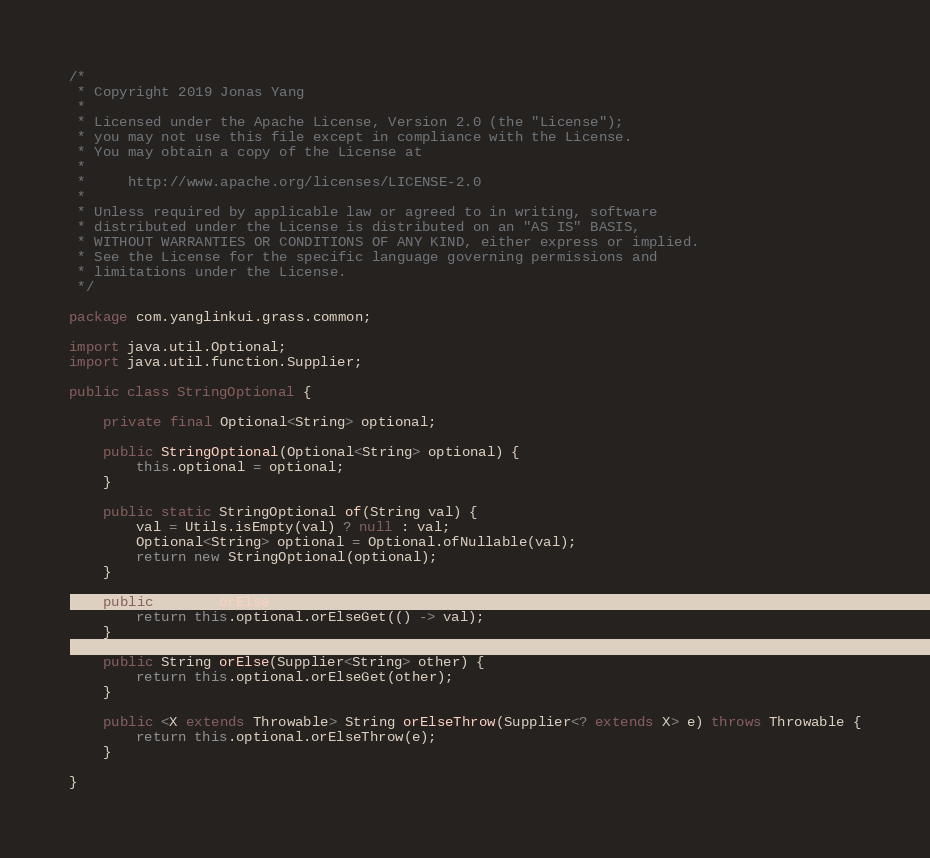Convert code to text. <code><loc_0><loc_0><loc_500><loc_500><_Java_>/*
 * Copyright 2019 Jonas Yang
 *
 * Licensed under the Apache License, Version 2.0 (the "License");
 * you may not use this file except in compliance with the License.
 * You may obtain a copy of the License at
 *
 *     http://www.apache.org/licenses/LICENSE-2.0
 *
 * Unless required by applicable law or agreed to in writing, software
 * distributed under the License is distributed on an "AS IS" BASIS,
 * WITHOUT WARRANTIES OR CONDITIONS OF ANY KIND, either express or implied.
 * See the License for the specific language governing permissions and
 * limitations under the License.
 */

package com.yanglinkui.grass.common;

import java.util.Optional;
import java.util.function.Supplier;

public class StringOptional {

    private final Optional<String> optional;

    public StringOptional(Optional<String> optional) {
        this.optional = optional;
    }

    public static StringOptional of(String val) {
        val = Utils.isEmpty(val) ? null : val;
        Optional<String> optional = Optional.ofNullable(val);
        return new StringOptional(optional);
    }

    public String orElse(String val) {
        return this.optional.orElseGet(() -> val);
    }

    public String orElse(Supplier<String> other) {
        return this.optional.orElseGet(other);
    }

    public <X extends Throwable> String orElseThrow(Supplier<? extends X> e) throws Throwable {
        return this.optional.orElseThrow(e);
    }

}
</code> 